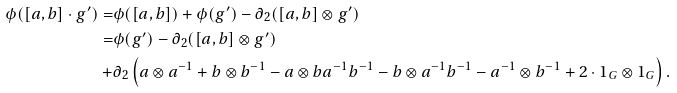Convert formula to latex. <formula><loc_0><loc_0><loc_500><loc_500>\phi ( [ a , b ] \cdot g ^ { \prime } ) = & \phi ( [ a , b ] ) + \phi ( g ^ { \prime } ) - \partial _ { 2 } ( [ a , b ] \otimes g ^ { \prime } ) \\ = & \phi ( g ^ { \prime } ) - \partial _ { 2 } ( [ a , b ] \otimes g ^ { \prime } ) \\ + & \partial _ { 2 } \left ( a \otimes a ^ { - 1 } + b \otimes b ^ { - 1 } - a \otimes b a ^ { - 1 } b ^ { - 1 } - b \otimes a ^ { - 1 } b ^ { - 1 } - a ^ { - 1 } \otimes b ^ { - 1 } + 2 \cdot 1 _ { G } \otimes 1 _ { G } \right ) .</formula> 